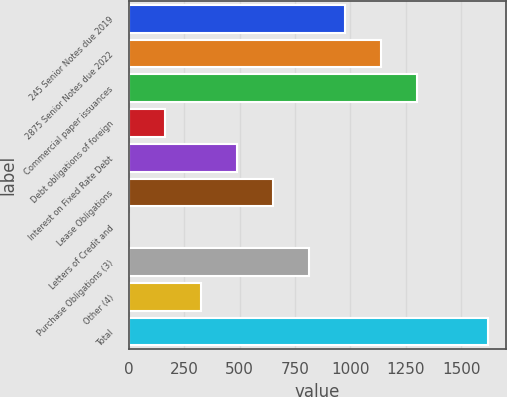Convert chart to OTSL. <chart><loc_0><loc_0><loc_500><loc_500><bar_chart><fcel>245 Senior Notes due 2019<fcel>2875 Senior Notes due 2022<fcel>Commercial paper issuances<fcel>Debt obligations of foreign<fcel>Interest on Fixed Rate Debt<fcel>Lease Obligations<fcel>Letters of Credit and<fcel>Purchase Obligations (3)<fcel>Other (4)<fcel>Total<nl><fcel>974.22<fcel>1135.94<fcel>1297.66<fcel>165.62<fcel>489.06<fcel>650.78<fcel>3.9<fcel>812.5<fcel>327.34<fcel>1621.1<nl></chart> 